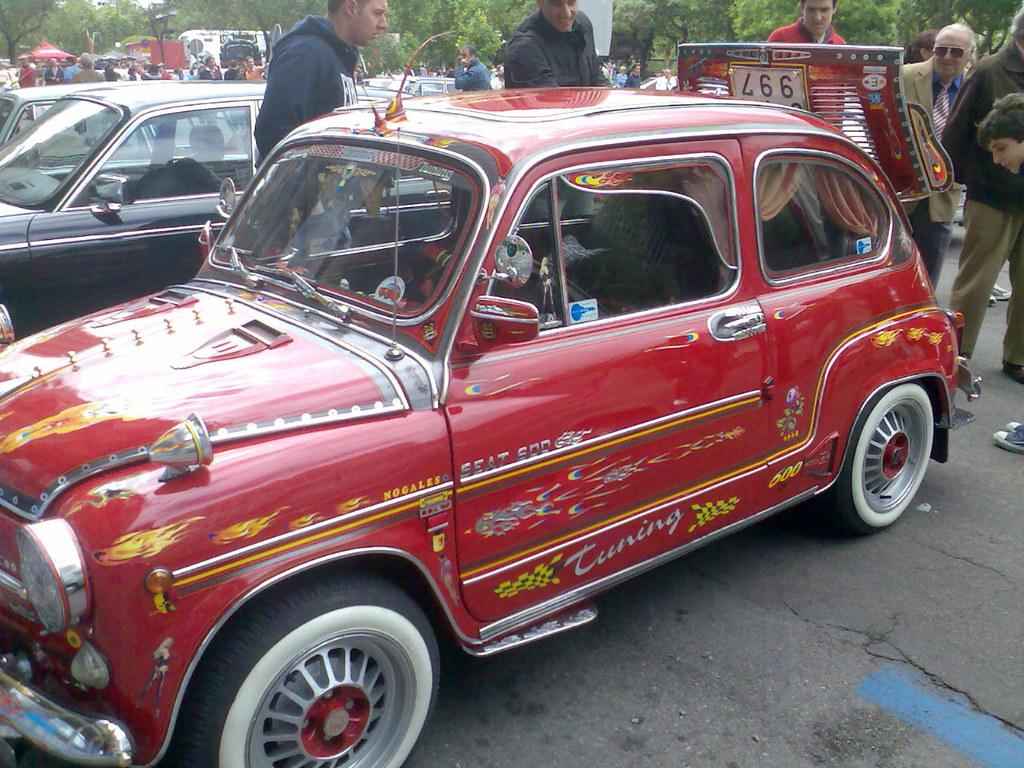<image>
Describe the image concisely. A vintage Seat 500 features flame decals on the sides. 